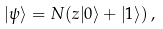<formula> <loc_0><loc_0><loc_500><loc_500>| \psi \rangle = N ( z | 0 \rangle + | 1 \rangle ) \, ,</formula> 